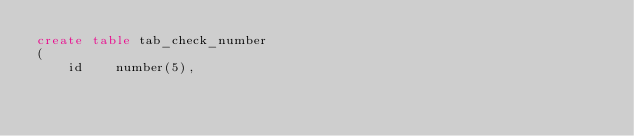<code> <loc_0><loc_0><loc_500><loc_500><_SQL_>create table tab_check_number
( 	
    id		number(5),</code> 